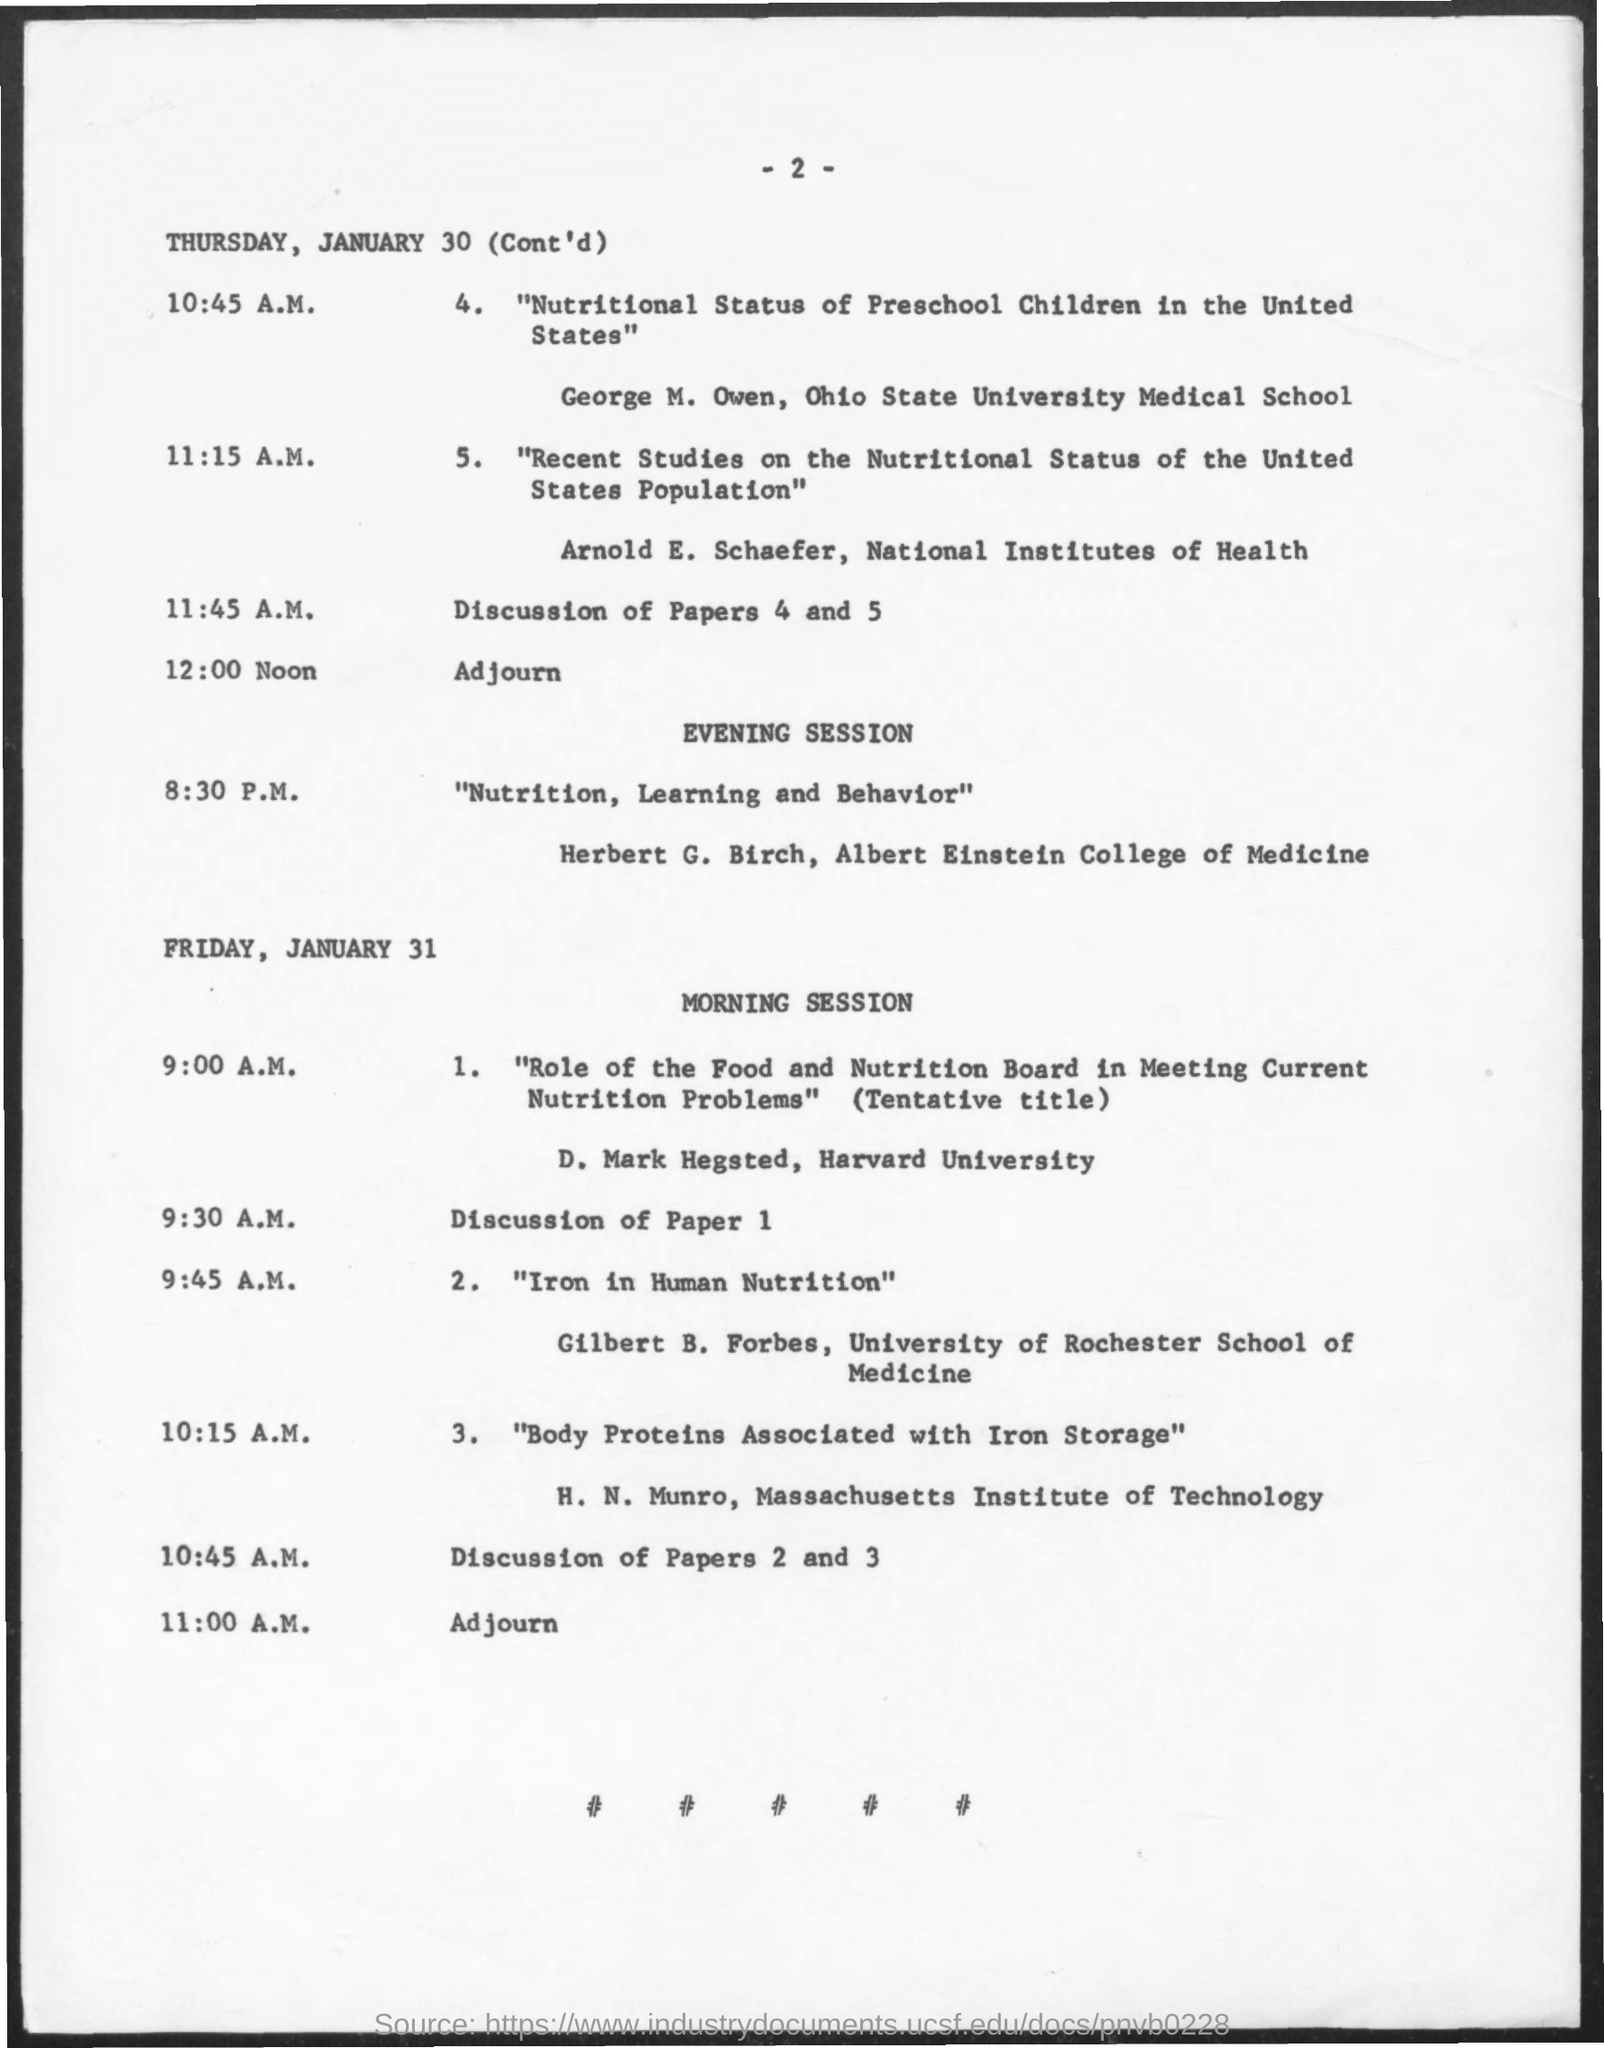Specify some key components in this picture. Arnold E. Schaefer conducted a paper on the topic "Recent Studies on the Nutritional Status of the United States population" on Thursday. The adjourn time for Thursday is scheduled for 12:00 Noon. D. Mark Hegsted is currently employed by Harvard University. The paper on the topic "Iron in Human Nutrition" was conducted by Gilbert B. Forbes on Friday. The paper on the topic "Role of the Food and Nutrition Board in Meeting Current Nutrition Problems" was conducted by D. Mark Hegsted on Friday. 